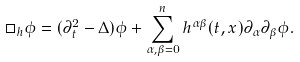<formula> <loc_0><loc_0><loc_500><loc_500>\square _ { h } \phi = ( \partial _ { t } ^ { 2 } - \Delta ) \phi + \sum _ { \alpha , \beta = 0 } ^ { n } h ^ { \alpha \beta } ( t , x ) \partial _ { \alpha } \partial _ { \beta } \phi .</formula> 